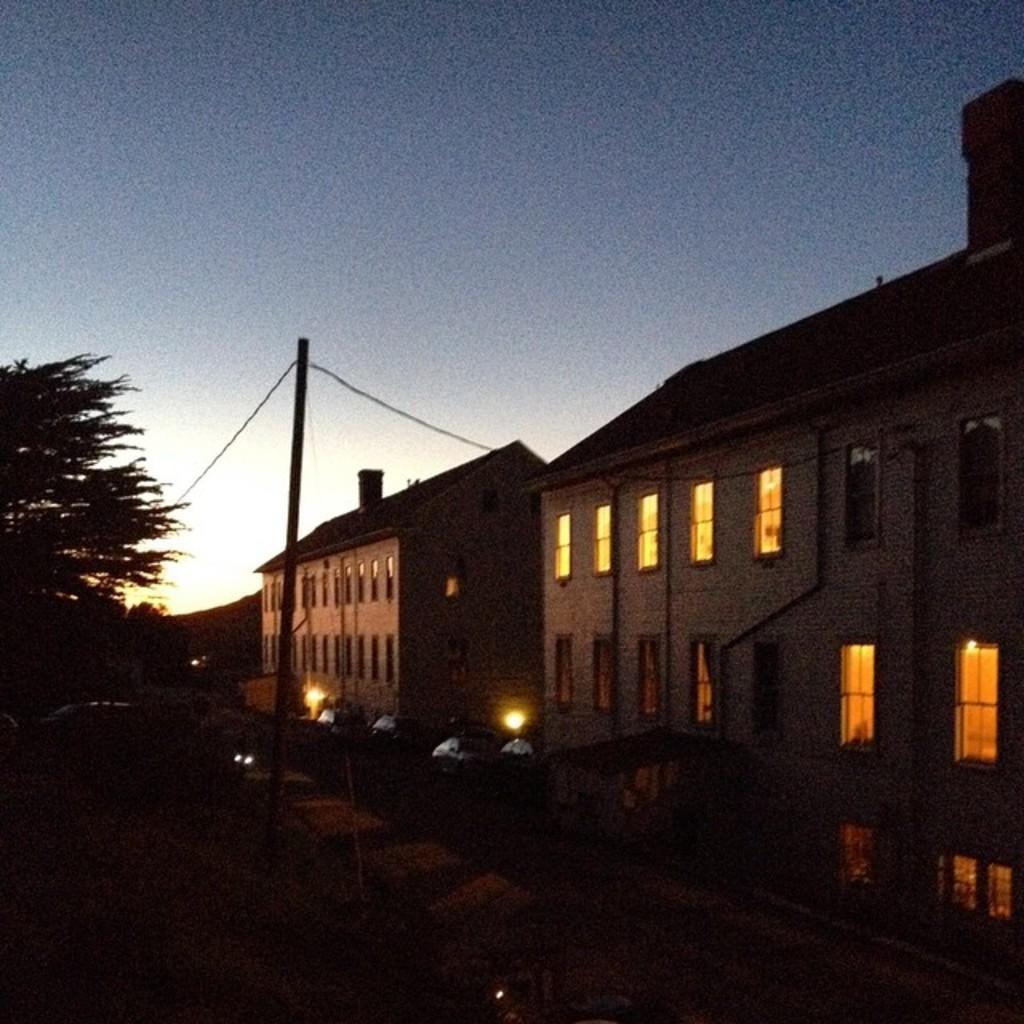Describe this image in one or two sentences. In this image there is a pole connected with the wire. There are street lights. Left side there is a vehicle. Left side there are trees. Background there are buildings. Top of the image there is sky. 